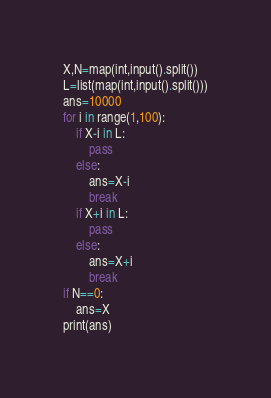<code> <loc_0><loc_0><loc_500><loc_500><_Python_>X,N=map(int,input().split())
L=list(map(int,input().split()))
ans=10000
for i in range(1,100):
    if X-i in L:
        pass
    else:
        ans=X-i
        break
    if X+i in L:
        pass
    else:
        ans=X+i
        break
if N==0:
    ans=X
print(ans)</code> 